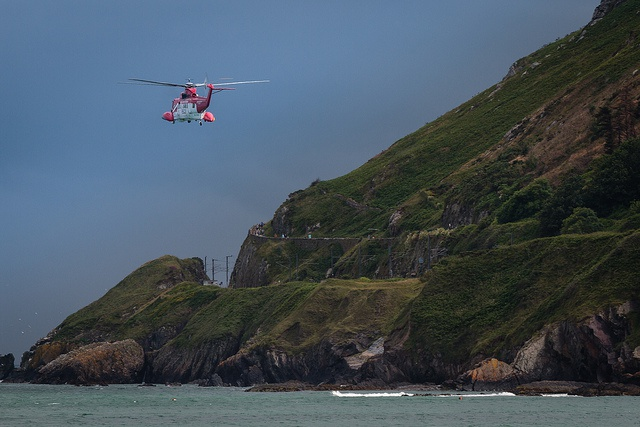Describe the objects in this image and their specific colors. I can see various objects in this image with different colors. 